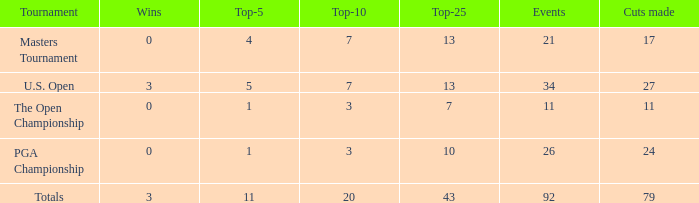Determine the combined score of the best-25 for pga championship and the first-5 lesser than None. 